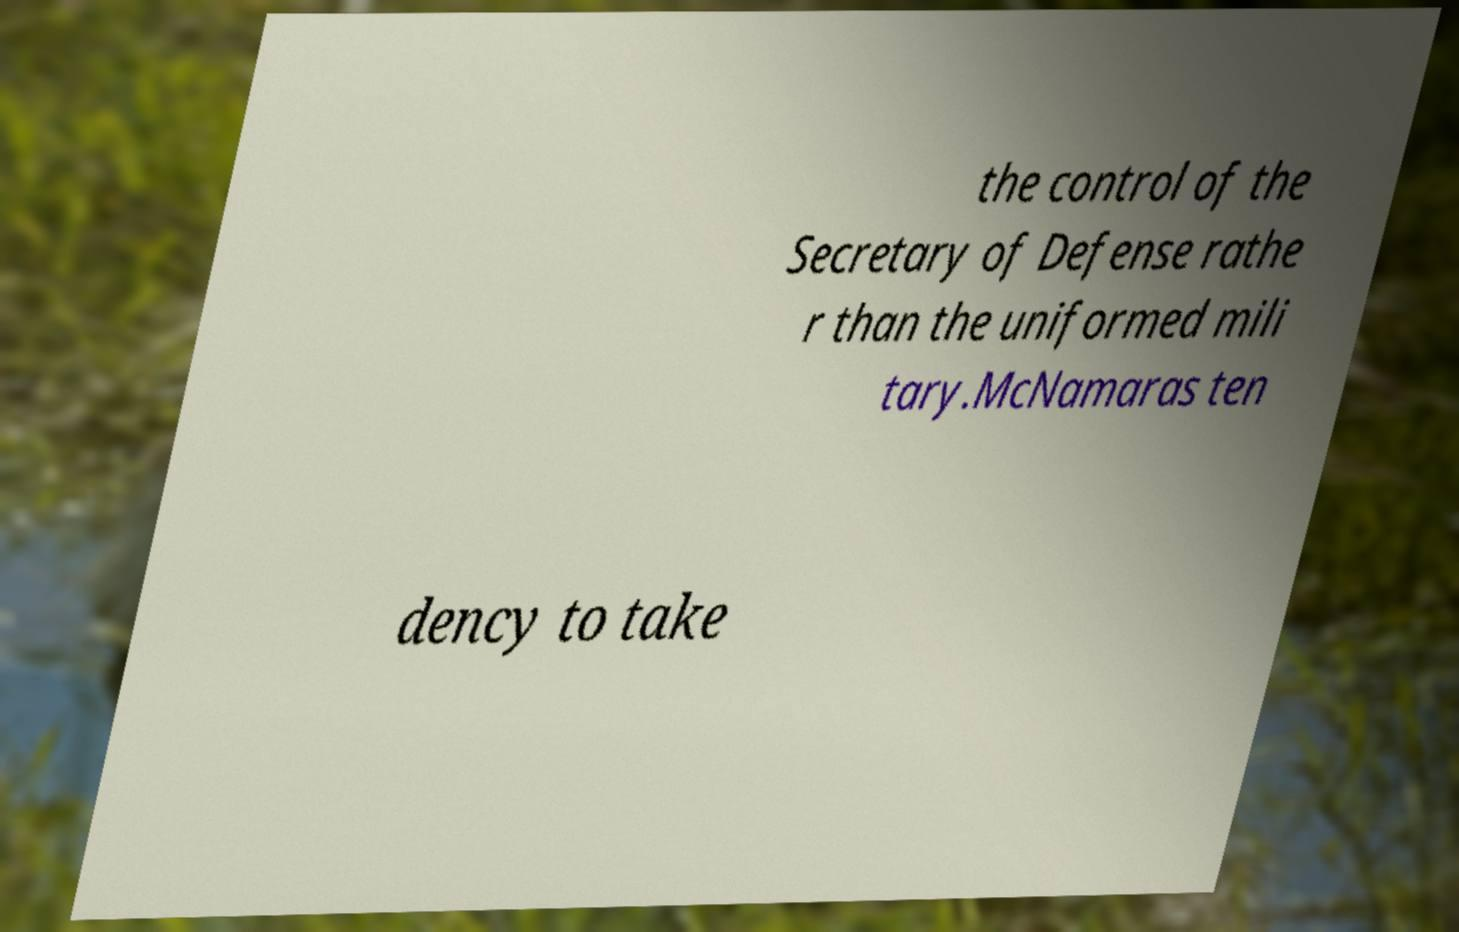What messages or text are displayed in this image? I need them in a readable, typed format. the control of the Secretary of Defense rathe r than the uniformed mili tary.McNamaras ten dency to take 